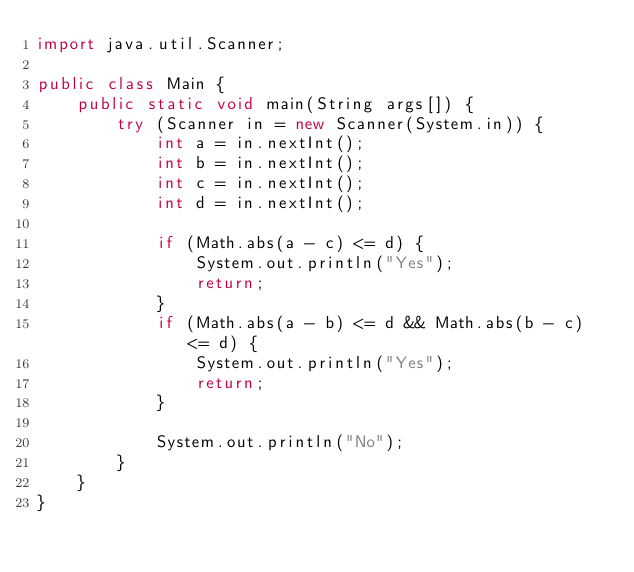Convert code to text. <code><loc_0><loc_0><loc_500><loc_500><_Java_>import java.util.Scanner;

public class Main {
    public static void main(String args[]) {
        try (Scanner in = new Scanner(System.in)) {
            int a = in.nextInt();
            int b = in.nextInt();
            int c = in.nextInt();
            int d = in.nextInt();

            if (Math.abs(a - c) <= d) {
                System.out.println("Yes");
                return;
            }
            if (Math.abs(a - b) <= d && Math.abs(b - c) <= d) {
                System.out.println("Yes");
                return;
            }

            System.out.println("No");
        }
    }
}
</code> 